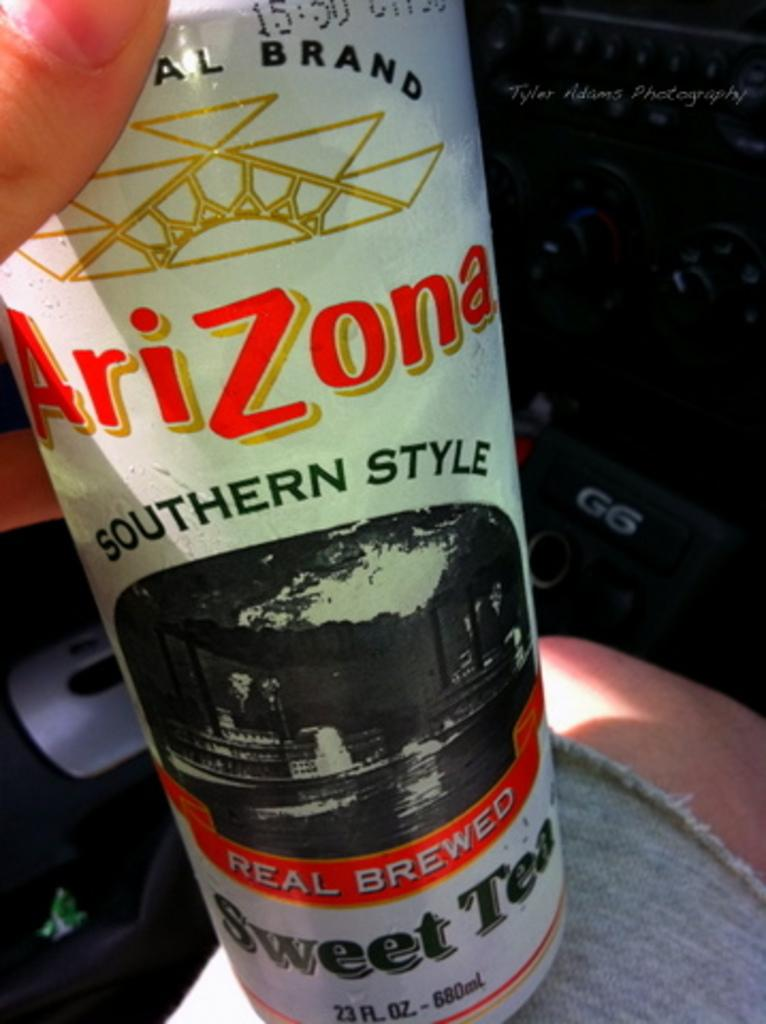<image>
Provide a brief description of the given image. A can of southern style sweet tea resting on someones knee. 